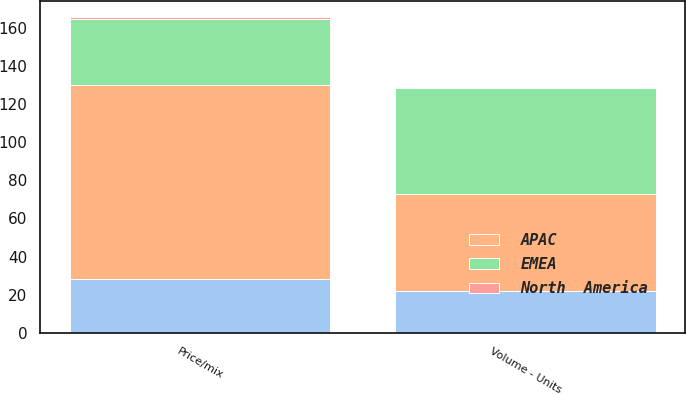Convert chart to OTSL. <chart><loc_0><loc_0><loc_500><loc_500><stacked_bar_chart><ecel><fcel>Volume - Units<fcel>Price/mix<nl><fcel>nan<fcel>21.7<fcel>28<nl><fcel>North  America<fcel>0.7<fcel>0.9<nl><fcel>EMEA<fcel>55.2<fcel>34.4<nl><fcel>APAC<fcel>51.2<fcel>102.1<nl></chart> 